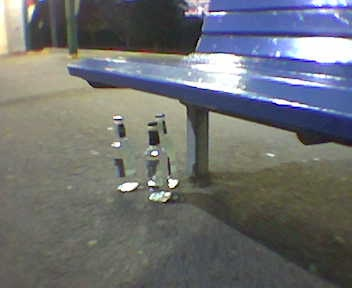Describe the objects in this image and their specific colors. I can see bench in ivory, blue, white, navy, and darkgray tones and bottle in ivory, gray, and darkgray tones in this image. 